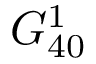Convert formula to latex. <formula><loc_0><loc_0><loc_500><loc_500>G _ { 4 0 } ^ { 1 }</formula> 